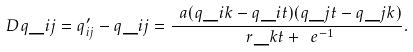Convert formula to latex. <formula><loc_0><loc_0><loc_500><loc_500>\ D q \_ { i j } = q ^ { \prime } _ { i j } - q \_ { i j } = \frac { \ a ( q \_ { i k } - q \_ { i t } ) ( q \_ { j t } - q \_ { j k } ) } { \ r \_ { k t } + \ e ^ { - 1 } } .</formula> 